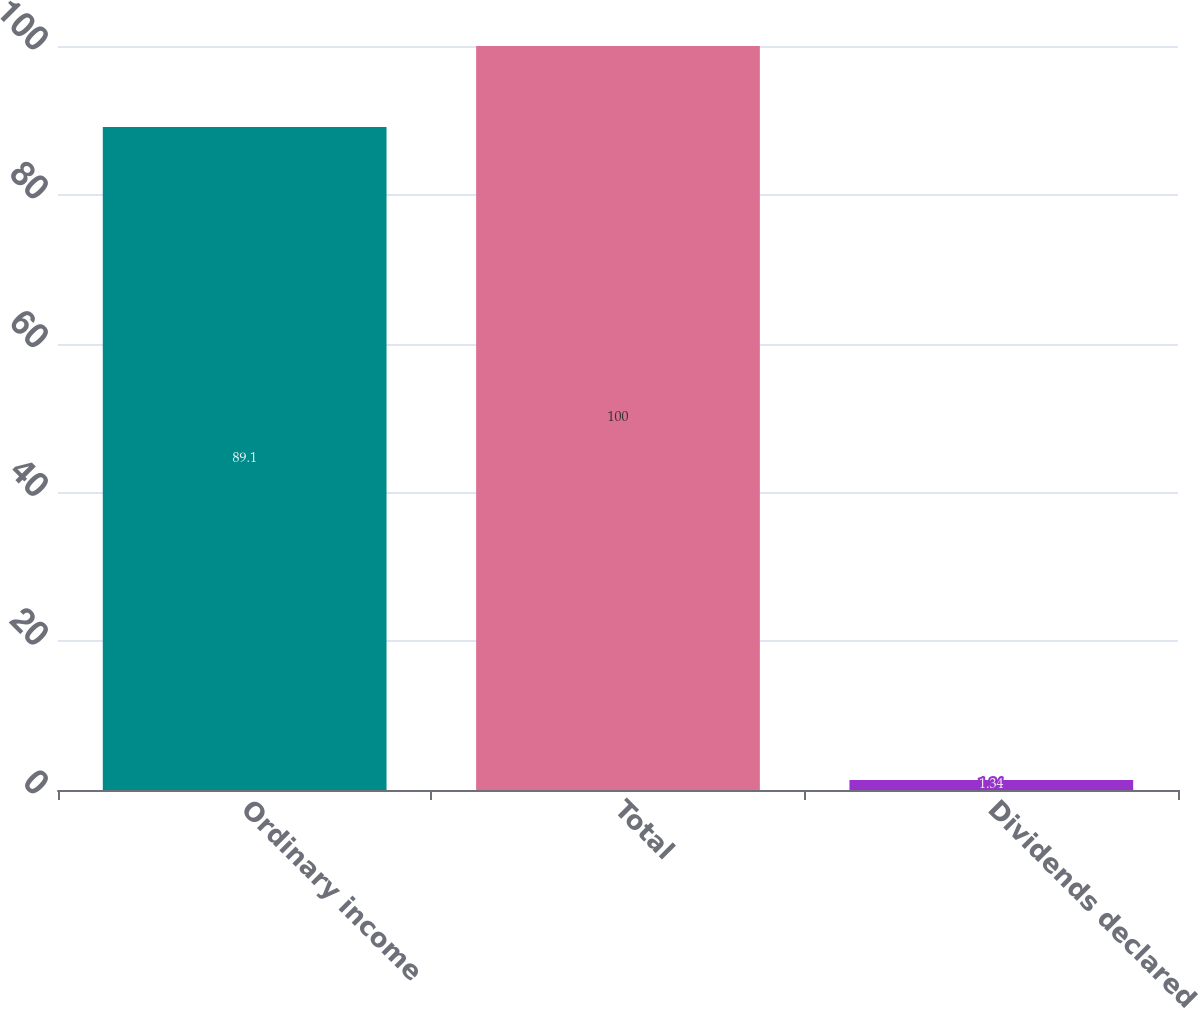Convert chart to OTSL. <chart><loc_0><loc_0><loc_500><loc_500><bar_chart><fcel>Ordinary income<fcel>Total<fcel>Dividends declared<nl><fcel>89.1<fcel>100<fcel>1.34<nl></chart> 